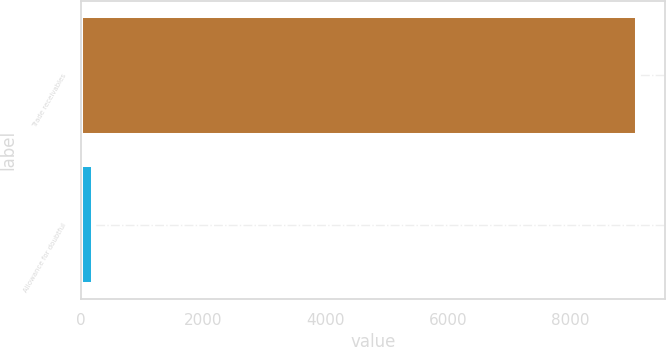Convert chart to OTSL. <chart><loc_0><loc_0><loc_500><loc_500><bar_chart><fcel>Trade receivables<fcel>Allowance for doubtful<nl><fcel>9091<fcel>211<nl></chart> 